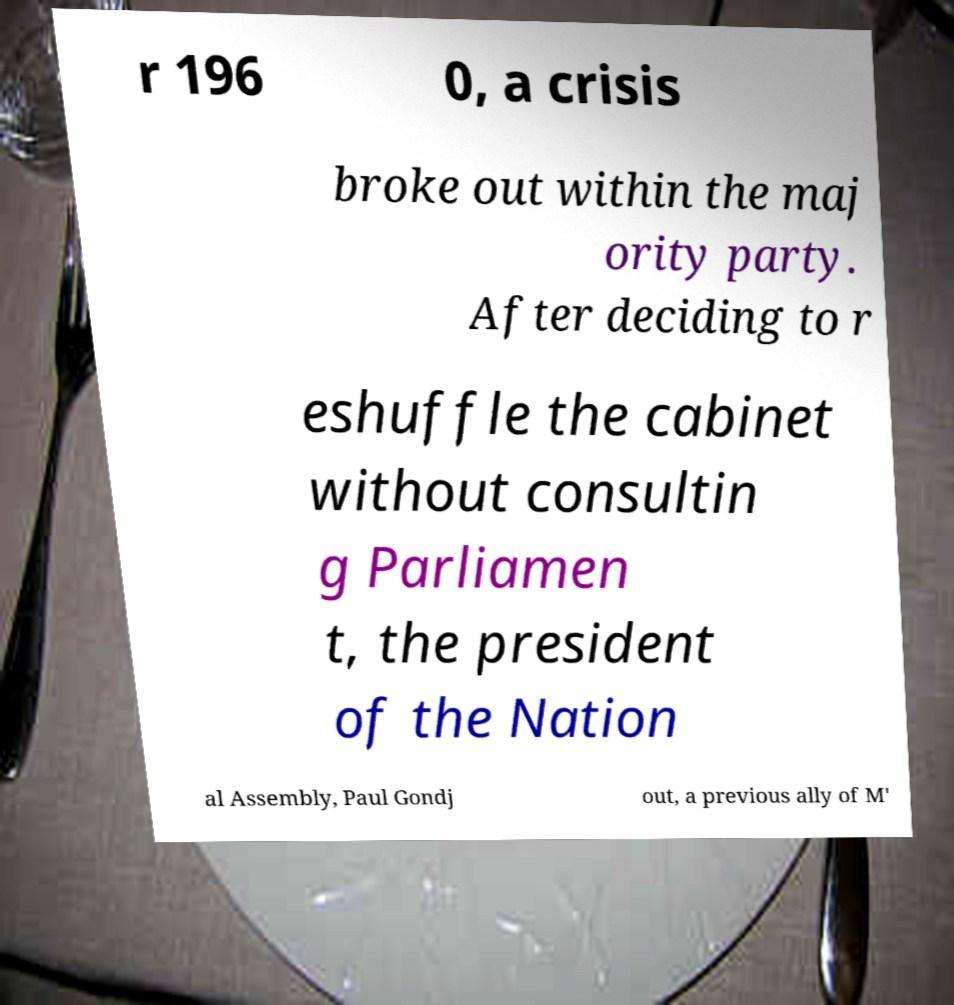Please read and relay the text visible in this image. What does it say? r 196 0, a crisis broke out within the maj ority party. After deciding to r eshuffle the cabinet without consultin g Parliamen t, the president of the Nation al Assembly, Paul Gondj out, a previous ally of M' 